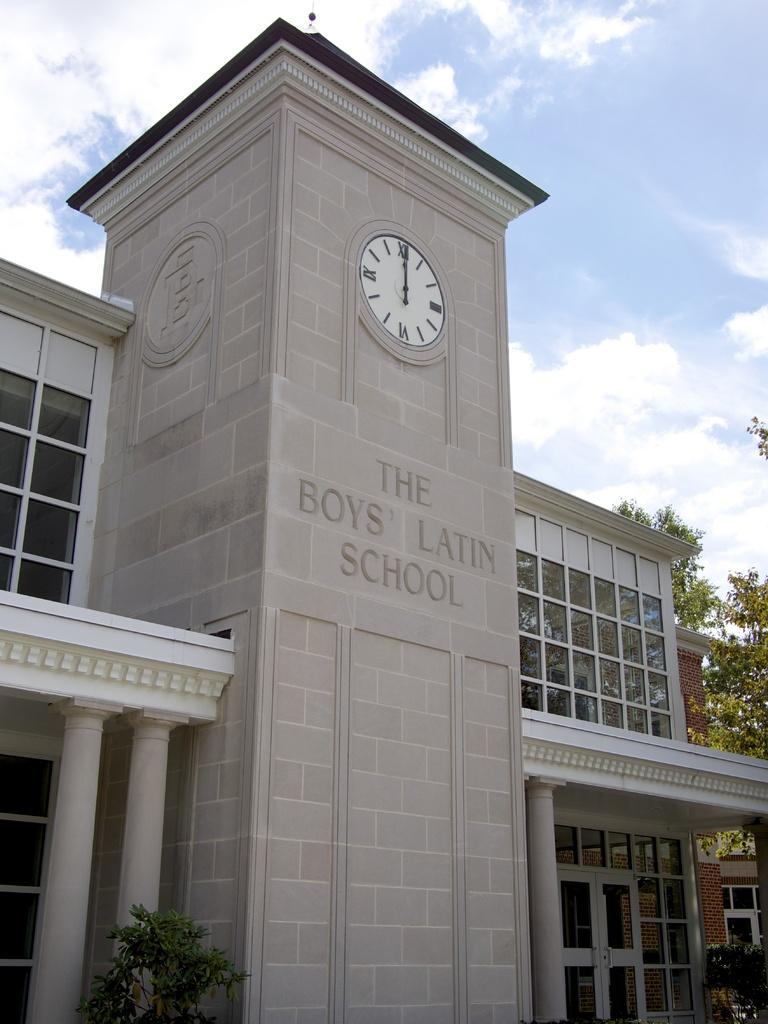<image>
Share a concise interpretation of the image provided. THE BOYS LATIN SCHOOL IS CAVED INTO THE BRICKS OF THE FRONT OF A BUILDING. 